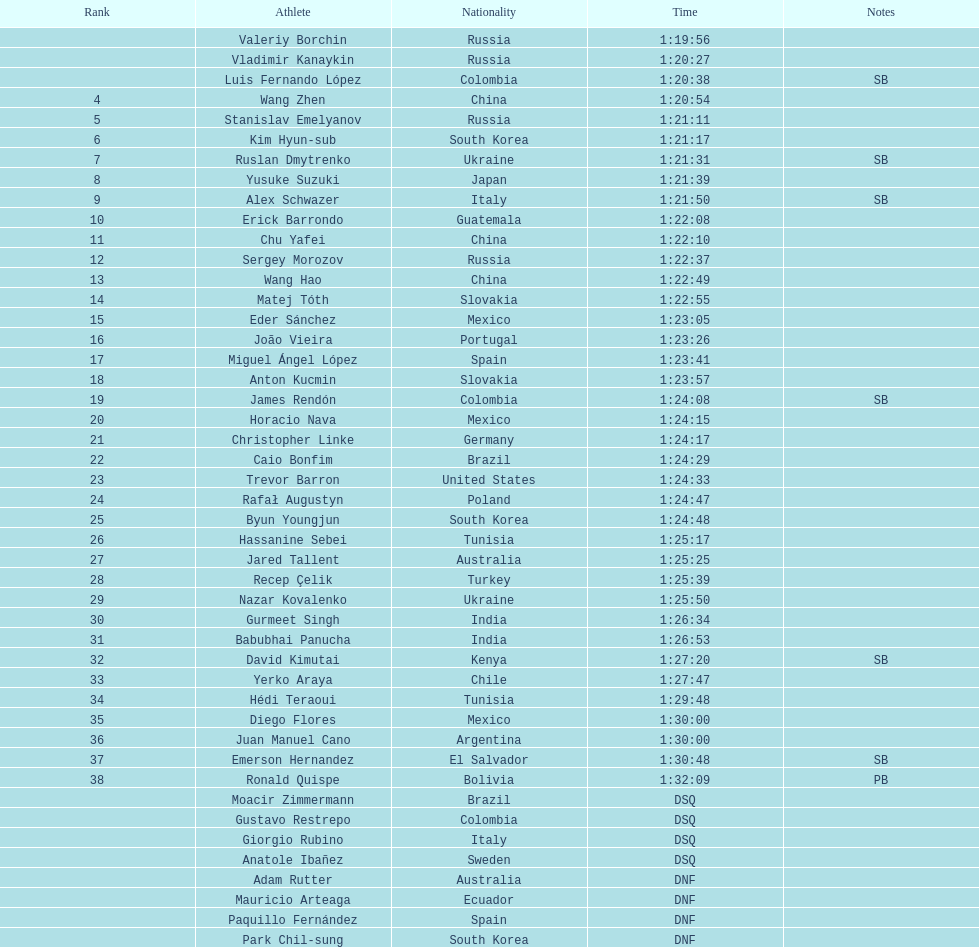How many rivals were from russia? 4. 